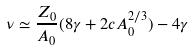<formula> <loc_0><loc_0><loc_500><loc_500>\nu \simeq \frac { Z _ { 0 } } { A _ { 0 } } ( 8 \gamma + 2 c A ^ { 2 / 3 } _ { 0 } ) - 4 \gamma</formula> 